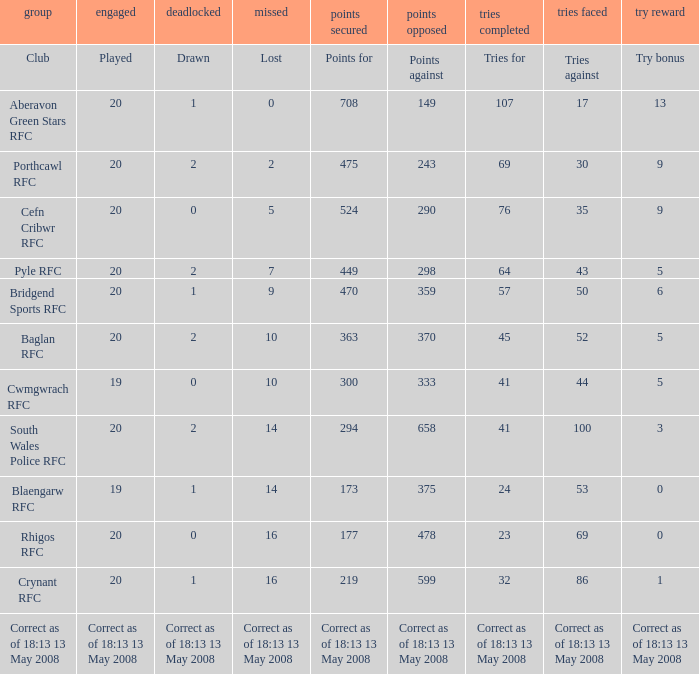What club has a played number of 19, and the lost of 14? Blaengarw RFC. 